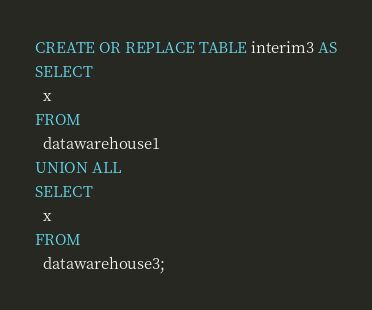<code> <loc_0><loc_0><loc_500><loc_500><_SQL_>CREATE OR REPLACE TABLE interim3 AS
SELECT
  x
FROM
  datawarehouse1
UNION ALL
SELECT
  x
FROM
  datawarehouse3;
</code> 